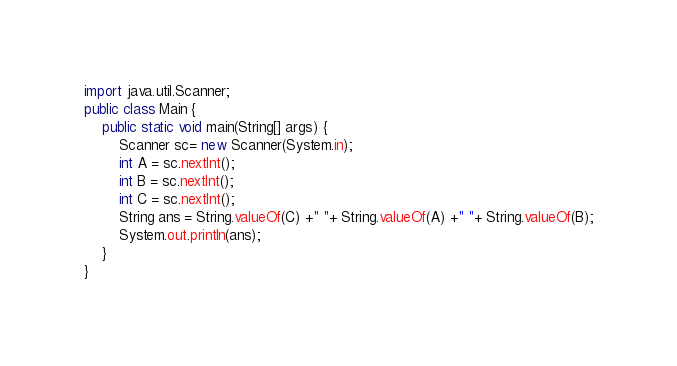<code> <loc_0><loc_0><loc_500><loc_500><_Java_>import java.util.Scanner;
public class Main {
    public static void main(String[] args) {
        Scanner sc= new Scanner(System.in);
        int A = sc.nextInt();
      	int B = sc.nextInt();
      	int C = sc.nextInt();
        String ans = String.valueOf(C) +" "+ String.valueOf(A) +" "+ String.valueOf(B);
      	System.out.println(ans);
    } 
}</code> 